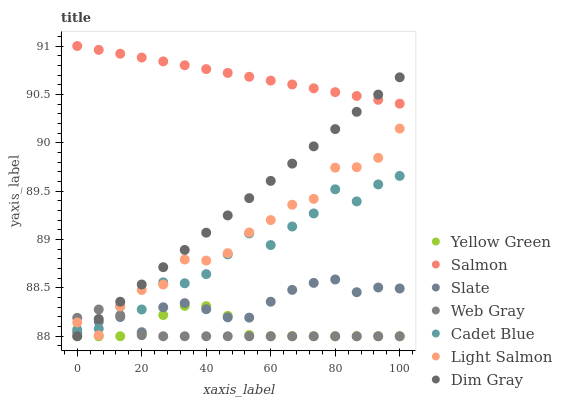Does Web Gray have the minimum area under the curve?
Answer yes or no. Yes. Does Salmon have the maximum area under the curve?
Answer yes or no. Yes. Does Cadet Blue have the minimum area under the curve?
Answer yes or no. No. Does Cadet Blue have the maximum area under the curve?
Answer yes or no. No. Is Salmon the smoothest?
Answer yes or no. Yes. Is Cadet Blue the roughest?
Answer yes or no. Yes. Is Yellow Green the smoothest?
Answer yes or no. No. Is Yellow Green the roughest?
Answer yes or no. No. Does Yellow Green have the lowest value?
Answer yes or no. Yes. Does Cadet Blue have the lowest value?
Answer yes or no. No. Does Salmon have the highest value?
Answer yes or no. Yes. Does Cadet Blue have the highest value?
Answer yes or no. No. Is Cadet Blue less than Salmon?
Answer yes or no. Yes. Is Salmon greater than Web Gray?
Answer yes or no. Yes. Does Dim Gray intersect Light Salmon?
Answer yes or no. Yes. Is Dim Gray less than Light Salmon?
Answer yes or no. No. Is Dim Gray greater than Light Salmon?
Answer yes or no. No. Does Cadet Blue intersect Salmon?
Answer yes or no. No. 